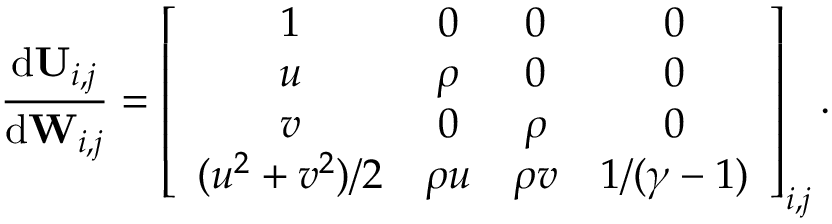<formula> <loc_0><loc_0><loc_500><loc_500>\frac { d U _ { i , j } } { d W _ { i , j } } = \left [ \begin{array} { c c c c } { 1 } & { 0 } & { 0 } & { 0 } \\ { u } & { \rho } & { 0 } & { 0 } \\ { v } & { 0 } & { \rho } & { 0 } \\ { ( u ^ { 2 } + v ^ { 2 } ) / 2 } & { \rho u } & { \rho v } & { 1 / ( \gamma - 1 ) } \end{array} \right ] _ { i , j } .</formula> 